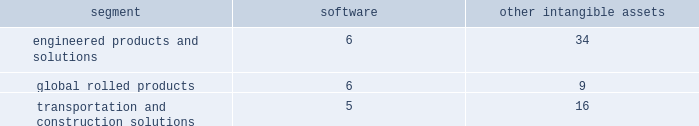Extrusions ( afe ) , which are all included in the engineered products and solutions segment , global rolled products , and building and construction systems , which is included in the transportation and construction solutions segment .
The estimated fair value for five of the six reporting units exceeded its respective carrying value , resulting in no impairment .
However , the estimated fair value of afe was lower than its carrying value .
As such , in the fourth quarter of 2017 , arconic recorded an impairment for the full amount of goodwill in the afe reporting unit of $ 719 .
The decrease in the afe fair value was primarily due to unfavorable performance that is impacting operating margins and a higher discount rate due to an increase in the risk-free rate of return , while the carrying value increased compared to prior year .
Goodwill impairment tests in 2016 and 2015 indicated that goodwill was not impaired for any of the company 2019s reporting units , except for the soft alloy extrusion business in brazil which is included in the transportation and construction solutions segment .
In the fourth quarter of 2015 , for the soft alloy extrusion business in brazil , the estimated fair value as determined by the dcf model was lower than the associated carrying value of its reporting unit 2019s goodwill .
As a result , management determined that the implied fair value of the reporting unit 2019s goodwill was zero .
Arconic recorded a goodwill impairment of $ 25 in 2015 .
The impairment of goodwill resulted from headwinds from the downturn in the brazilian economy and the continued erosion of gross margin despite the execution of cost reduction strategies .
As a result of the goodwill impairment , there is no goodwill remaining for the reporting unit .
Other intangible assets .
Intangible assets with indefinite useful lives are not amortized while intangible assets with finite useful lives are amortized generally on a straight-line basis over the periods benefited .
The table details the weighted- average useful lives of software and other intangible assets by reporting segment ( numbers in years ) : .
Revenue recognition .
Arconic recognizes revenues when title , ownership , and risk of loss pass to the customer , all of which occurs upon shipment or delivery of the product and is based on the applicable shipping terms .
The shipping terms vary across all businesses and depend on the product , the country of origin , and the type of transportation ( truck , train , or vessel ) .
In certain circumstances , arconic receives advanced payments from its customers for product to be delivered in future periods .
These advanced payments are recorded as deferred revenue until the product is delivered and title and risk of loss have passed to the customer in accordance with the terms of the contract .
Deferred revenue is included in other current liabilities and other noncurrent liabilities and deferred credits on the accompanying consolidated balance sheet .
Environmental matters .
Expenditures for current operations are expensed or capitalized , as appropriate .
Expenditures relating to existing conditions caused by past operations , which will not contribute to future revenues , are expensed .
Liabilities are recorded when remediation costs are probable and can be reasonably estimated .
The liability may include costs such as site investigations , consultant fees , feasibility studies , outside contractors , and monitoring expenses .
Estimates are generally not discounted or reduced by potential claims for recovery .
Claims for recovery are recognized when probable and as agreements are reached with third parties .
The estimates also include costs related to other potentially responsible parties to the extent that arconic has reason to believe such parties will not fully pay their proportionate share .
The liability is continuously reviewed and adjusted to reflect current remediation progress , prospective estimates of required activity , and other factors that may be relevant , including changes in technology or regulations .
Litigation matters .
For asserted claims and assessments , liabilities are recorded when an unfavorable outcome of a matter is deemed to be probable and the loss is reasonably estimable .
Management determines the likelihood of an unfavorable outcome based on many factors such as the nature of the matter , available defenses and case strategy , progress of the matter , views and opinions of legal counsel and other advisors , applicability and success of appeals processes , and the outcome of similar historical matters , among others .
Once an unfavorable outcome is deemed probable , management weighs the probability of estimated losses , and the most reasonable loss estimate is recorded .
If an unfavorable outcome of a matter is deemed to be reasonably possible , then the matter is disclosed and no liability is recorded .
With respect to unasserted claims or assessments , management must first determine that the probability that an assertion will be made is likely , then , a determination as to the likelihood of an unfavorable outcome and the ability to reasonably estimate the potential loss is made .
Legal matters are reviewed on a continuous basis to determine if there has been a change in management 2019s judgment regarding the likelihood of an unfavorable outcome or the estimate of a potential loss .
Income taxes .
The provision for income taxes is determined using the asset and liability approach of accounting for income taxes .
Under this approach , the provision for income taxes represents income taxes paid or payable ( or received or receivable ) .
What is the difference between the weighted- average useful lives of software for the global rolled products segment and the transportation and construction solutions one? 
Rationale: it is the difference between the number of years .
Computations: (6 - 5)
Answer: 1.0. 